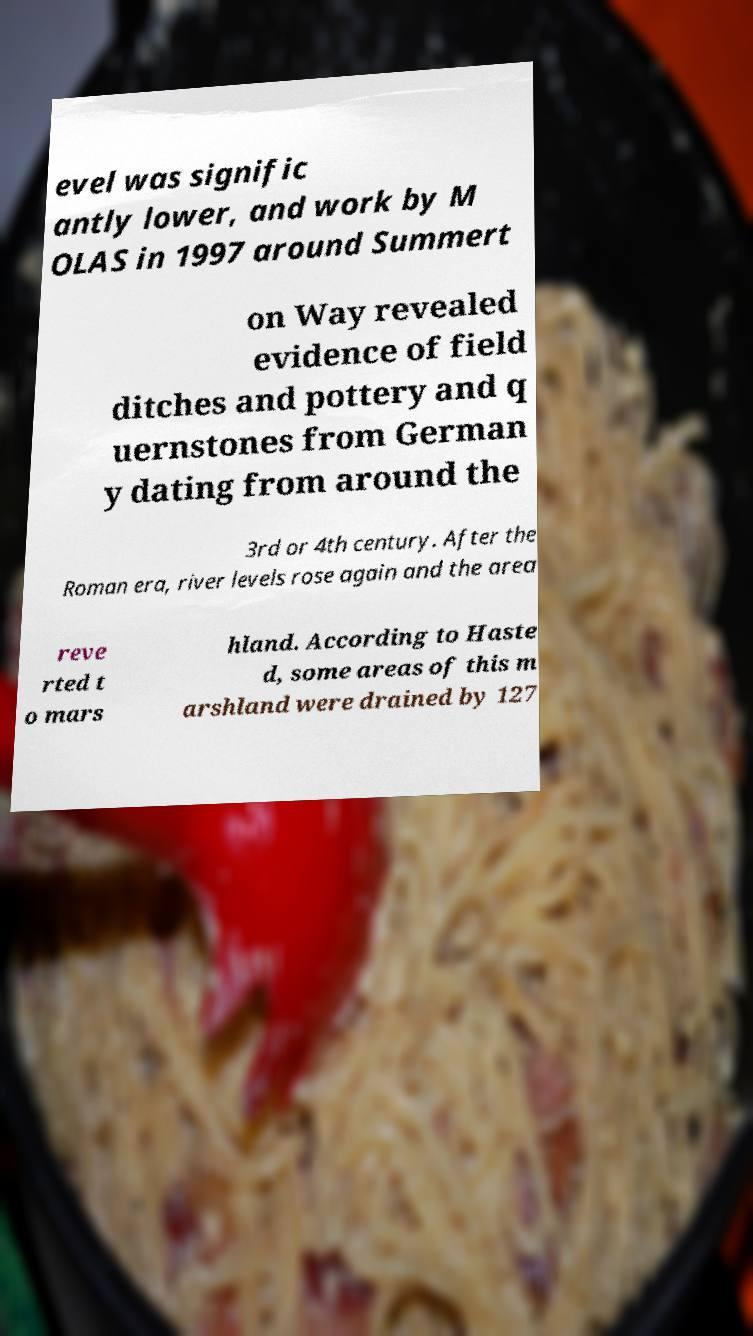Can you accurately transcribe the text from the provided image for me? evel was signific antly lower, and work by M OLAS in 1997 around Summert on Way revealed evidence of field ditches and pottery and q uernstones from German y dating from around the 3rd or 4th century. After the Roman era, river levels rose again and the area reve rted t o mars hland. According to Haste d, some areas of this m arshland were drained by 127 